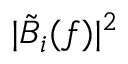Convert formula to latex. <formula><loc_0><loc_0><loc_500><loc_500>| \tilde { B } _ { i } ( f ) | ^ { 2 }</formula> 